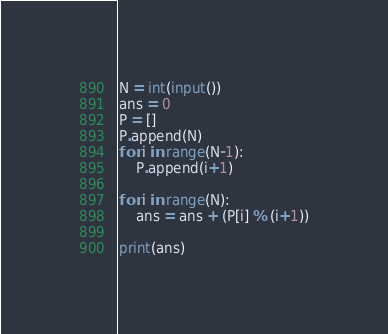<code> <loc_0><loc_0><loc_500><loc_500><_Python_>N = int(input())
ans = 0
P = []
P.append(N)
for i in range(N-1):
    P.append(i+1)

for i in range(N):
    ans = ans + (P[i] % (i+1))

print(ans)</code> 